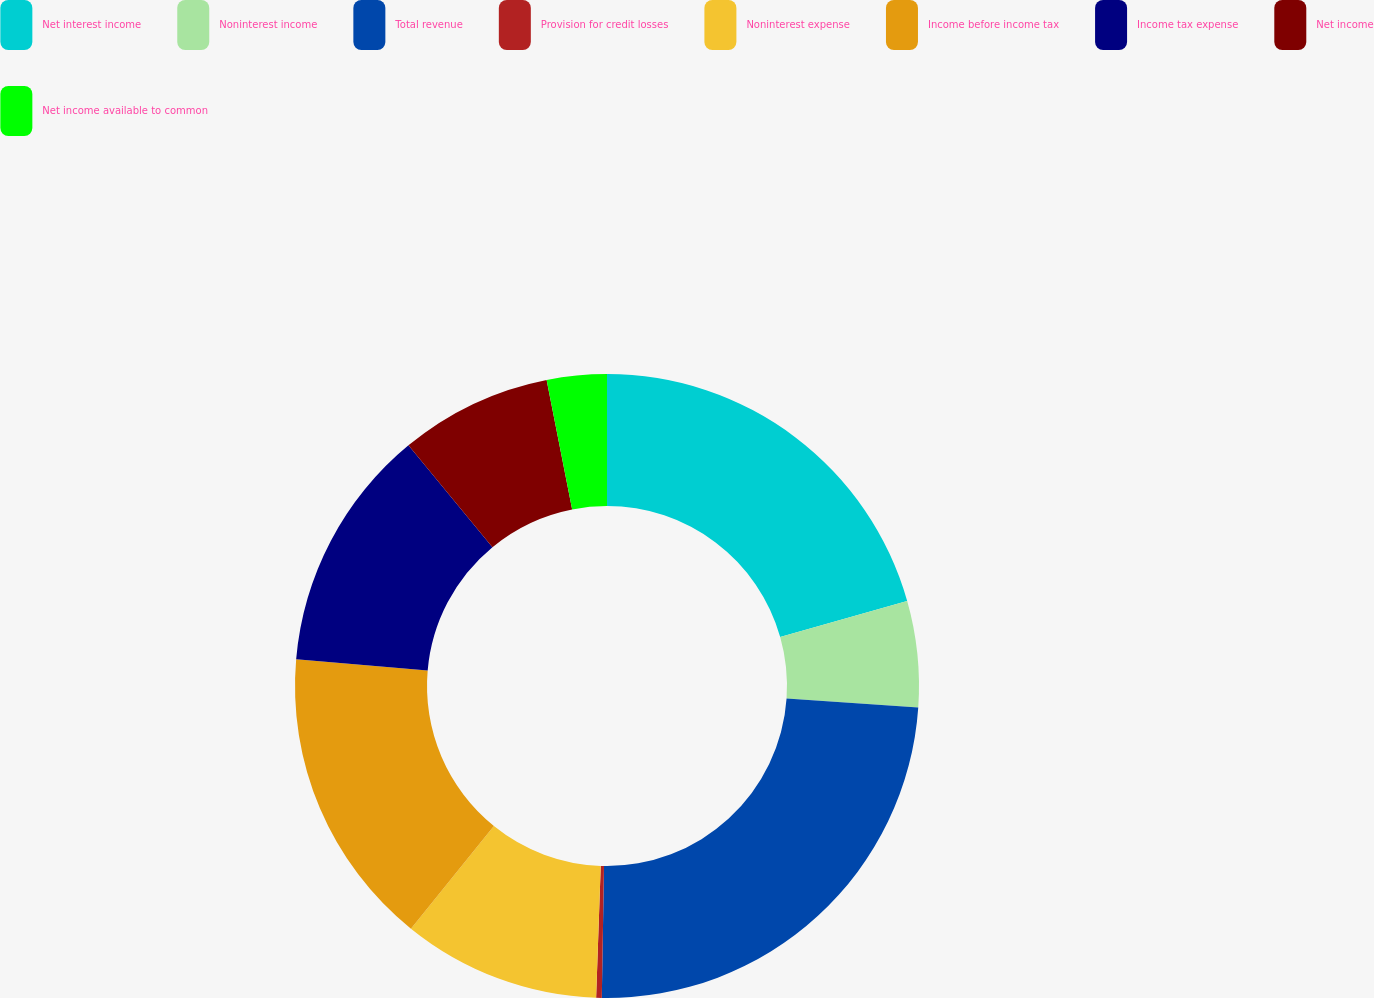Convert chart to OTSL. <chart><loc_0><loc_0><loc_500><loc_500><pie_chart><fcel>Net interest income<fcel>Noninterest income<fcel>Total revenue<fcel>Provision for credit losses<fcel>Noninterest expense<fcel>Income before income tax<fcel>Income tax expense<fcel>Net income<fcel>Net income available to common<nl><fcel>20.61%<fcel>5.49%<fcel>24.17%<fcel>0.29%<fcel>10.26%<fcel>15.56%<fcel>12.65%<fcel>7.88%<fcel>3.1%<nl></chart> 